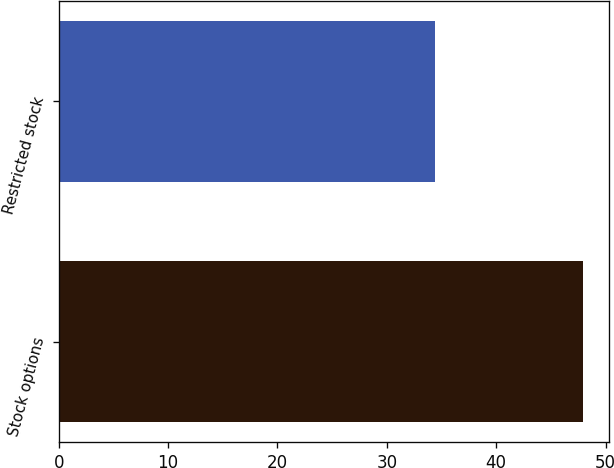Convert chart to OTSL. <chart><loc_0><loc_0><loc_500><loc_500><bar_chart><fcel>Stock options<fcel>Restricted stock<nl><fcel>47.9<fcel>34.4<nl></chart> 